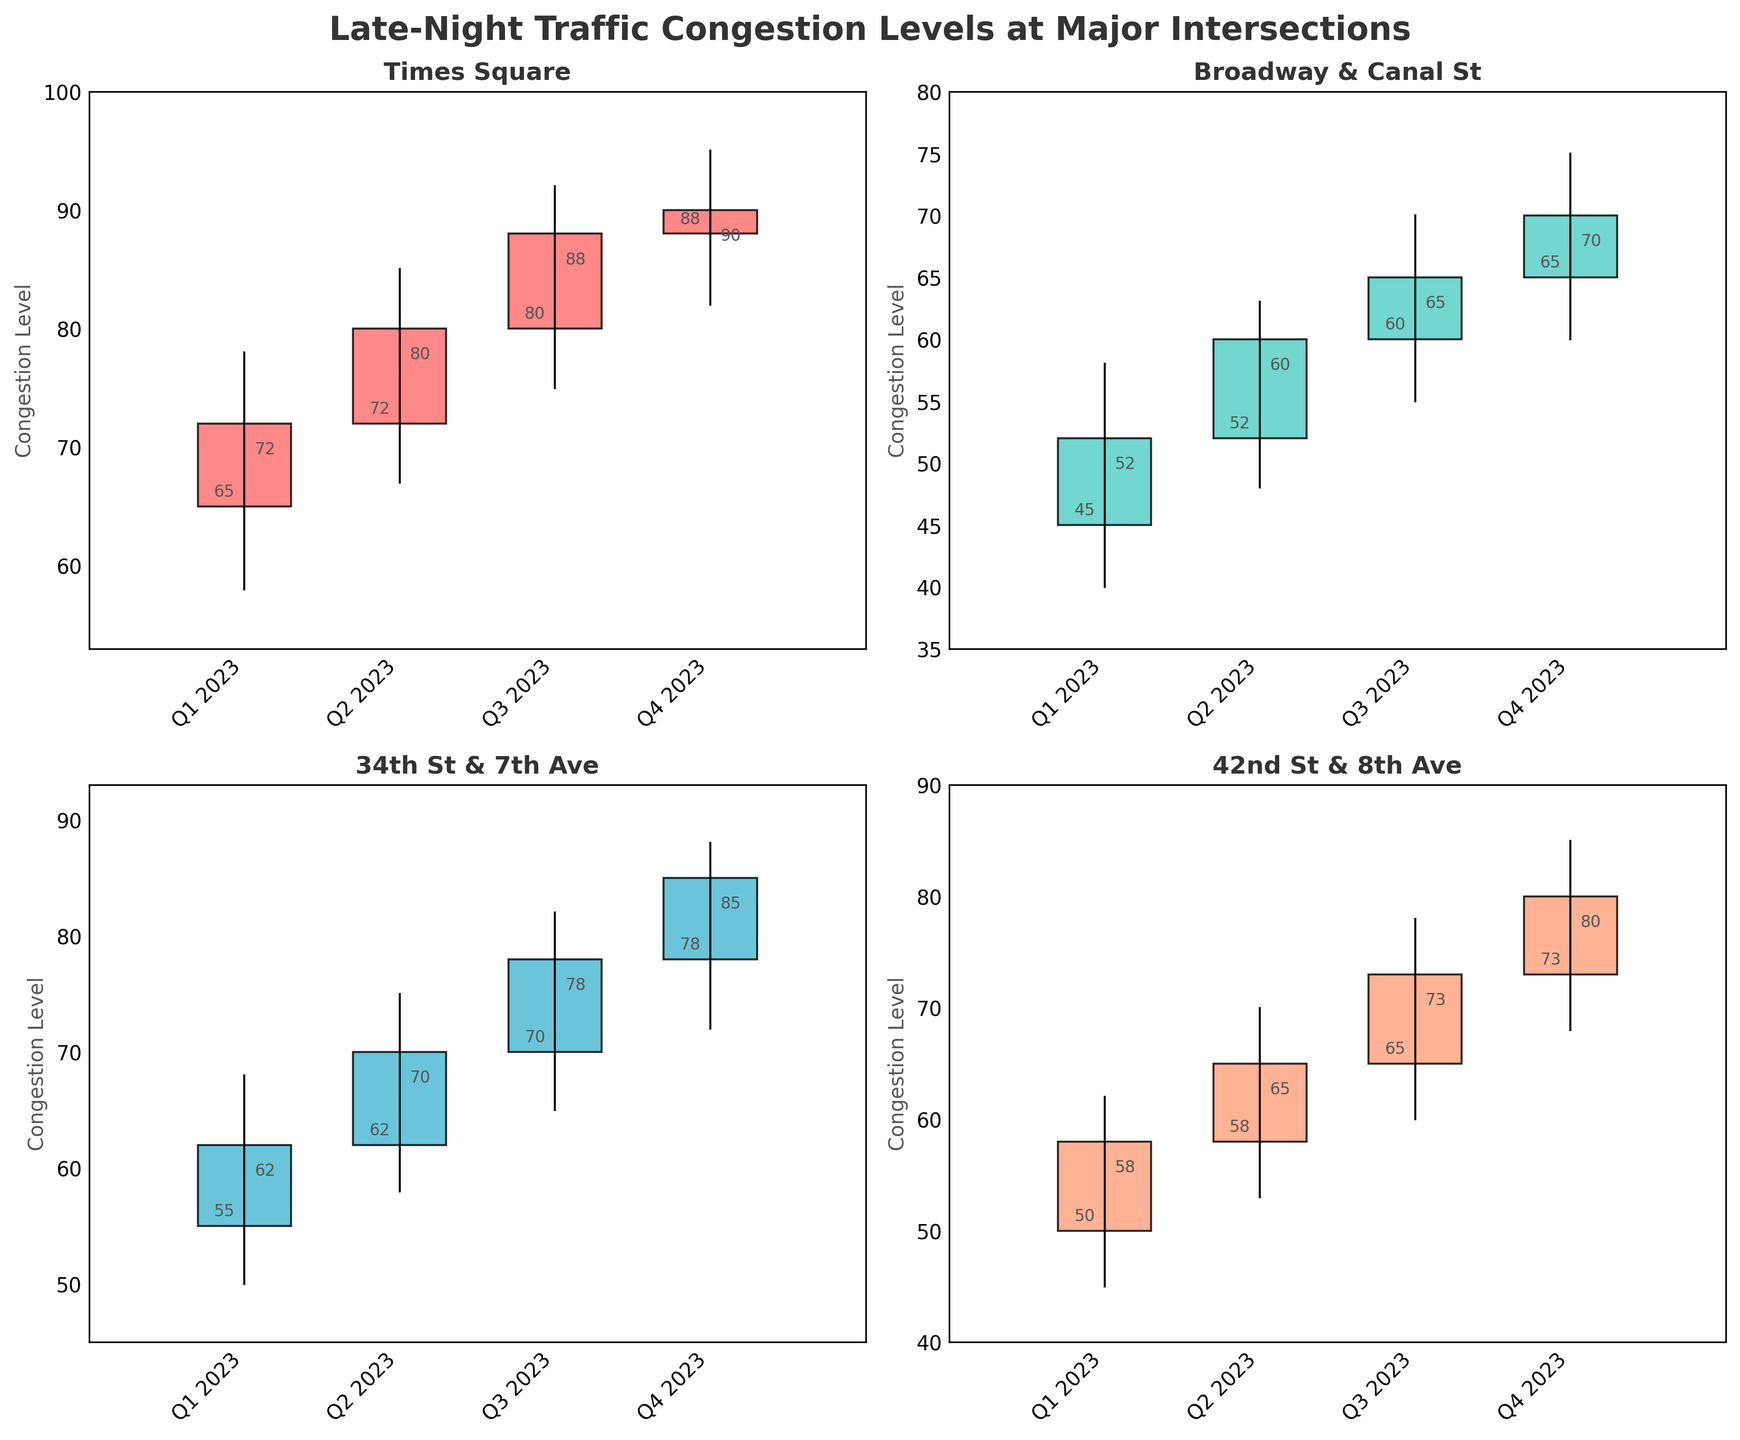What's the title of the figure? The title is usually located at the top of the figure. In this case, it reads "Late-Night Traffic Congestion Levels at Major Intersections".
Answer: Late-Night Traffic Congestion Levels at Major Intersections Which intersection showed the highest congestion level in Q4 2023? Look at the four intersections for Q4 2023 and find the one with the highest 'High' value. Times Square has the highest congestion level at 95.
Answer: Times Square What colors are used to indicate the bars where the Close value is higher than the Open value? The bars where the Close value is higher than the Open value are colored with specific colors for each intersection. These colors are various shades different from the color used when Close is less than Open.
Answer: Various shades (e.g., reds, greens, blues) Which intersection has the closest Open and Close values in Q3 2023? Compare the differences between Open and Close values for Q3 2023 at each intersection. 42nd St & 8th Ave has an Open of 65 and a Close of 73, which is the smallest difference.
Answer: 42nd St & 8th Ave What was the Open value for Broadway & Canal St in Q2 2023? Look for Broadway & Canal St in the Q2 2023 column and read the Open value from the chart. The Open value is 52.
Answer: 52 Which quarter did 34th St & 7th Ave experience the highest increase in congestion level? Calculate the difference between Open and Close values for each quarter of 34th St & 7th Ave. The quarter with the highest increase is Q4 2023 (a rise from 78 to 85).
Answer: Q4 2023 How many intersections experienced an increase in congestion from Q1 to Q4 2023? Check each intersection's Open value in Q1 2023 and Close value in Q4 2023. All intersections (Times Square, Broadway & Canal St, 34th St & 7th Ave, 42nd St & 8th Ave) experienced an increase.
Answer: 4 Which intersections have a lower congestion level at their lowest point in any quarter for the entire year? Identify the 'Low' values for each intersection over all quarters. Broadway & Canal St has the lowest point at 40, which is lower than other intersections' lowest points.
Answer: Broadway & Canal St What is the average closing congestion level for all intersections in Q2 2023? Sum the Close values for all intersections in Q2 2023 and then divide by the number of intersections. (80 + 60 + 70 + 65) / 4 = 68.75.
Answer: 68.75 